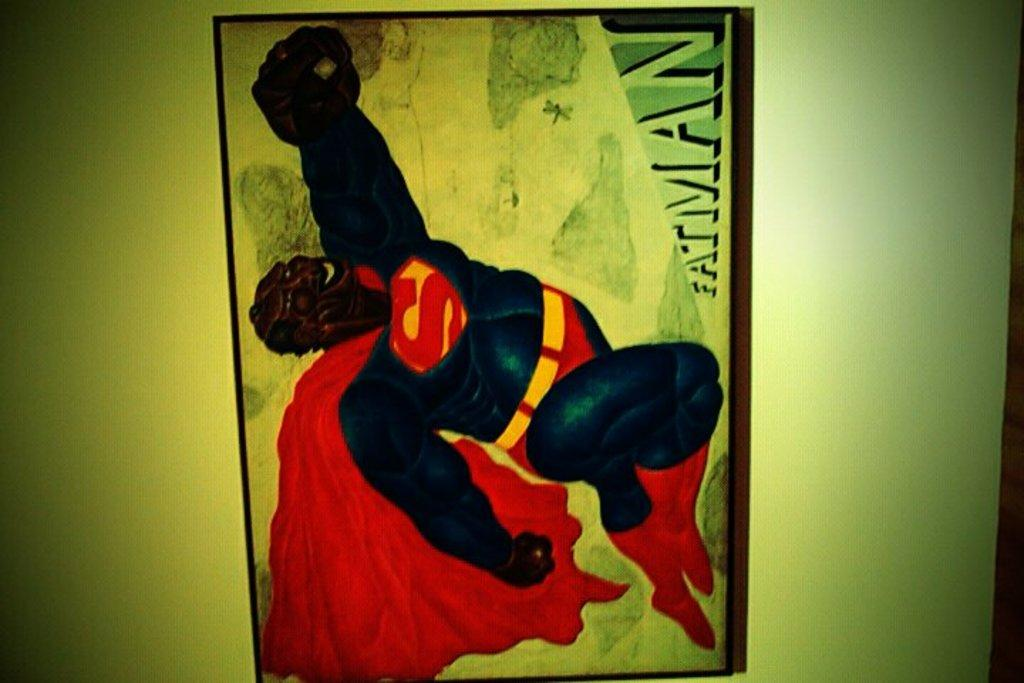Provide a one-sentence caption for the provided image. A cartoonish drawing of a black man wearing a Superman costume with the name Fatman written at the bottom. 